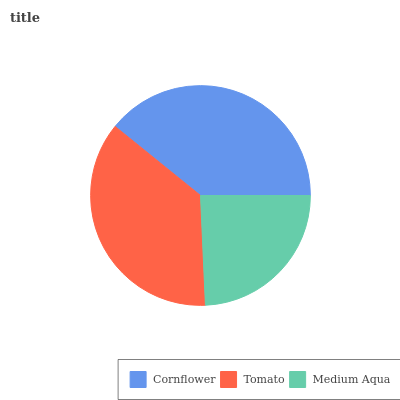Is Medium Aqua the minimum?
Answer yes or no. Yes. Is Cornflower the maximum?
Answer yes or no. Yes. Is Tomato the minimum?
Answer yes or no. No. Is Tomato the maximum?
Answer yes or no. No. Is Cornflower greater than Tomato?
Answer yes or no. Yes. Is Tomato less than Cornflower?
Answer yes or no. Yes. Is Tomato greater than Cornflower?
Answer yes or no. No. Is Cornflower less than Tomato?
Answer yes or no. No. Is Tomato the high median?
Answer yes or no. Yes. Is Tomato the low median?
Answer yes or no. Yes. Is Cornflower the high median?
Answer yes or no. No. Is Medium Aqua the low median?
Answer yes or no. No. 